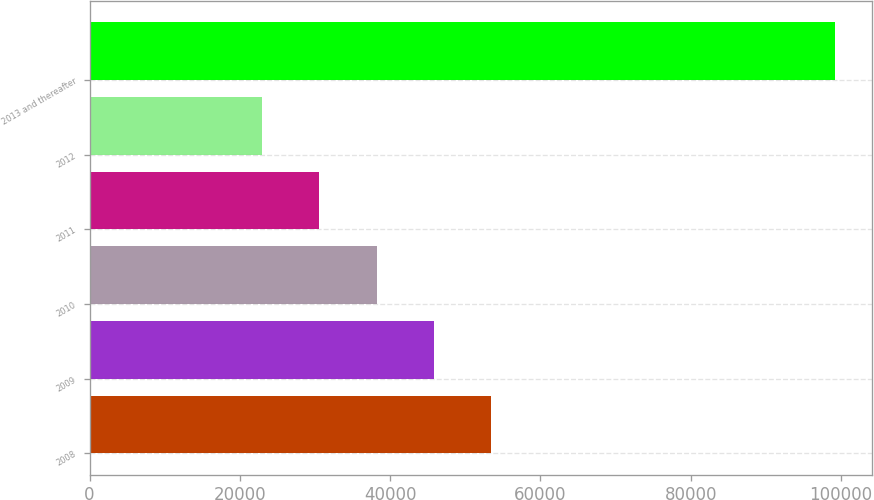<chart> <loc_0><loc_0><loc_500><loc_500><bar_chart><fcel>2008<fcel>2009<fcel>2010<fcel>2011<fcel>2012<fcel>2013 and thereafter<nl><fcel>53436<fcel>45809<fcel>38182<fcel>30555<fcel>22928<fcel>99198<nl></chart> 